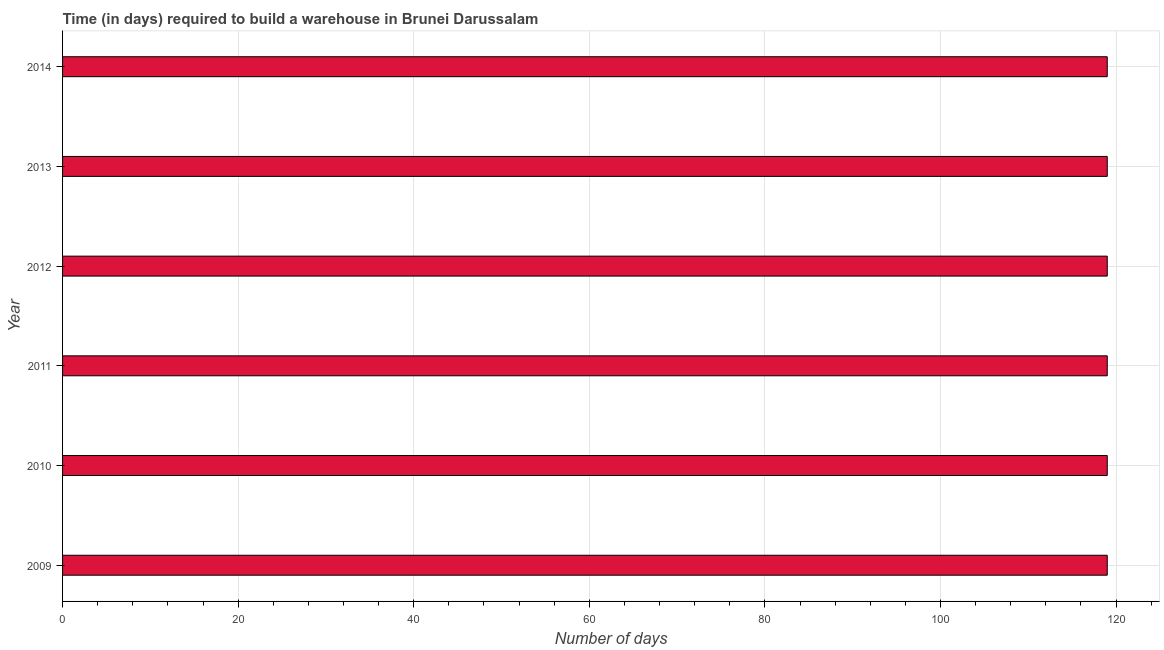Does the graph contain grids?
Keep it short and to the point. Yes. What is the title of the graph?
Provide a succinct answer. Time (in days) required to build a warehouse in Brunei Darussalam. What is the label or title of the X-axis?
Your answer should be very brief. Number of days. What is the time required to build a warehouse in 2013?
Make the answer very short. 119. Across all years, what is the maximum time required to build a warehouse?
Provide a succinct answer. 119. Across all years, what is the minimum time required to build a warehouse?
Your answer should be compact. 119. What is the sum of the time required to build a warehouse?
Offer a terse response. 714. What is the average time required to build a warehouse per year?
Offer a terse response. 119. What is the median time required to build a warehouse?
Keep it short and to the point. 119. Do a majority of the years between 2009 and 2011 (inclusive) have time required to build a warehouse greater than 84 days?
Make the answer very short. Yes. What is the ratio of the time required to build a warehouse in 2011 to that in 2013?
Your response must be concise. 1. Is the time required to build a warehouse in 2010 less than that in 2013?
Provide a succinct answer. No. What is the difference between the highest and the lowest time required to build a warehouse?
Your response must be concise. 0. In how many years, is the time required to build a warehouse greater than the average time required to build a warehouse taken over all years?
Make the answer very short. 0. How many bars are there?
Your answer should be very brief. 6. Are all the bars in the graph horizontal?
Offer a terse response. Yes. How many years are there in the graph?
Provide a succinct answer. 6. Are the values on the major ticks of X-axis written in scientific E-notation?
Offer a terse response. No. What is the Number of days of 2009?
Your answer should be very brief. 119. What is the Number of days in 2010?
Provide a short and direct response. 119. What is the Number of days of 2011?
Your answer should be compact. 119. What is the Number of days in 2012?
Offer a very short reply. 119. What is the Number of days in 2013?
Offer a terse response. 119. What is the Number of days in 2014?
Offer a very short reply. 119. What is the difference between the Number of days in 2009 and 2012?
Give a very brief answer. 0. What is the difference between the Number of days in 2009 and 2013?
Your answer should be compact. 0. What is the difference between the Number of days in 2010 and 2011?
Provide a short and direct response. 0. What is the difference between the Number of days in 2010 and 2014?
Your answer should be compact. 0. What is the difference between the Number of days in 2013 and 2014?
Make the answer very short. 0. What is the ratio of the Number of days in 2009 to that in 2010?
Make the answer very short. 1. What is the ratio of the Number of days in 2009 to that in 2012?
Provide a succinct answer. 1. What is the ratio of the Number of days in 2009 to that in 2013?
Offer a terse response. 1. What is the ratio of the Number of days in 2009 to that in 2014?
Offer a very short reply. 1. What is the ratio of the Number of days in 2011 to that in 2013?
Make the answer very short. 1. What is the ratio of the Number of days in 2011 to that in 2014?
Offer a terse response. 1. What is the ratio of the Number of days in 2012 to that in 2013?
Your answer should be compact. 1. What is the ratio of the Number of days in 2013 to that in 2014?
Your answer should be very brief. 1. 